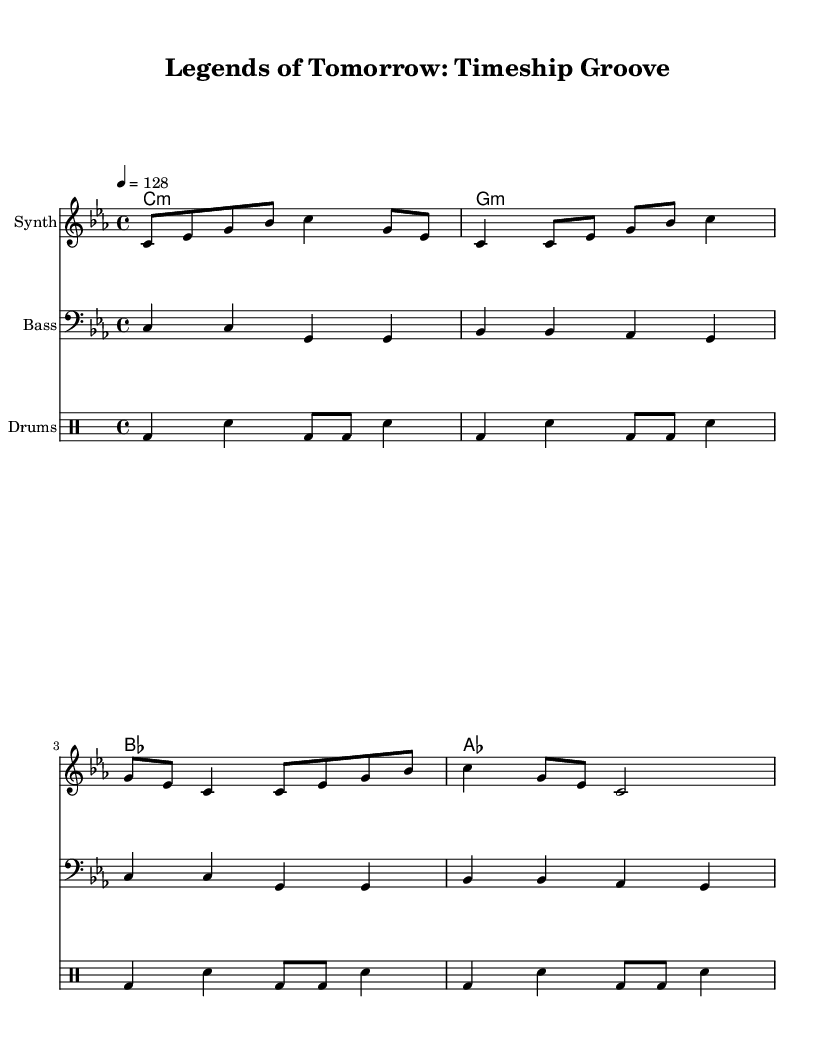What is the key signature of this music? The key signature is indicated at the beginning of the staff, showing three flats which is characteristic of C minor.
Answer: C minor What is the time signature of this music? The time signature is shown at the beginning of the score as 4/4, meaning there are four beats in each measure and the quarter note gets one beat.
Answer: 4/4 What is the tempo marking for this piece? The tempo marking is indicated at the start as "4 = 128," which means the quarter note is played at a speed of 128 beats per minute.
Answer: 128 How many measures are there in the synth melody? By counting the measures in the synth melody line, there are a total of four measures before the sequence repeats.
Answer: 4 Which instrument plays the bass line? The instrument specified for the bass line is noted in the staff title as "Bass," which shows it's the bass part in the arrangement.
Answer: Bass What kind of rhythm pattern is used for the drums? The drum pattern is constructed using a mix of bass drum and snare drum hits structured in a repetitive cycle, typical of dance music.
Answer: Repetitive pattern What is the last chord used in this music? The last chord shown in the chord progression is "as," indicating an A-flat major chord is the final one played in the sequence.
Answer: A-flat 